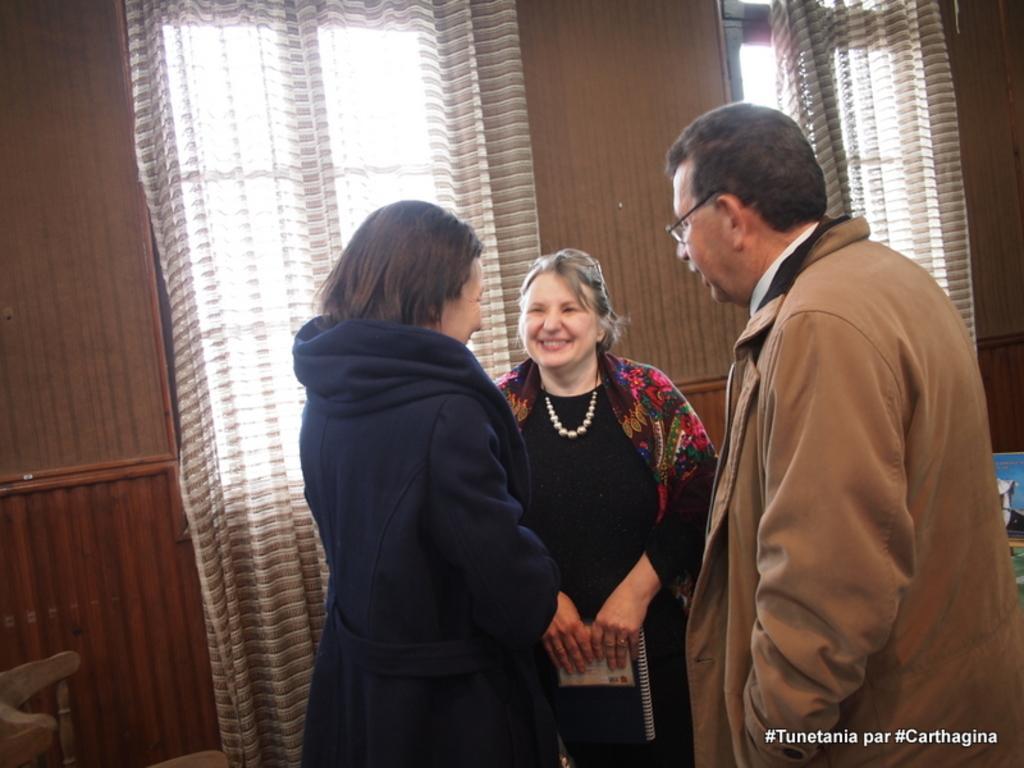Describe this image in one or two sentences. In this image I can see three persons standing. In front the person is wearing black color dress and holding the book. In the background I can see few curtains, windows and I can see the wooden wall in brown color. 